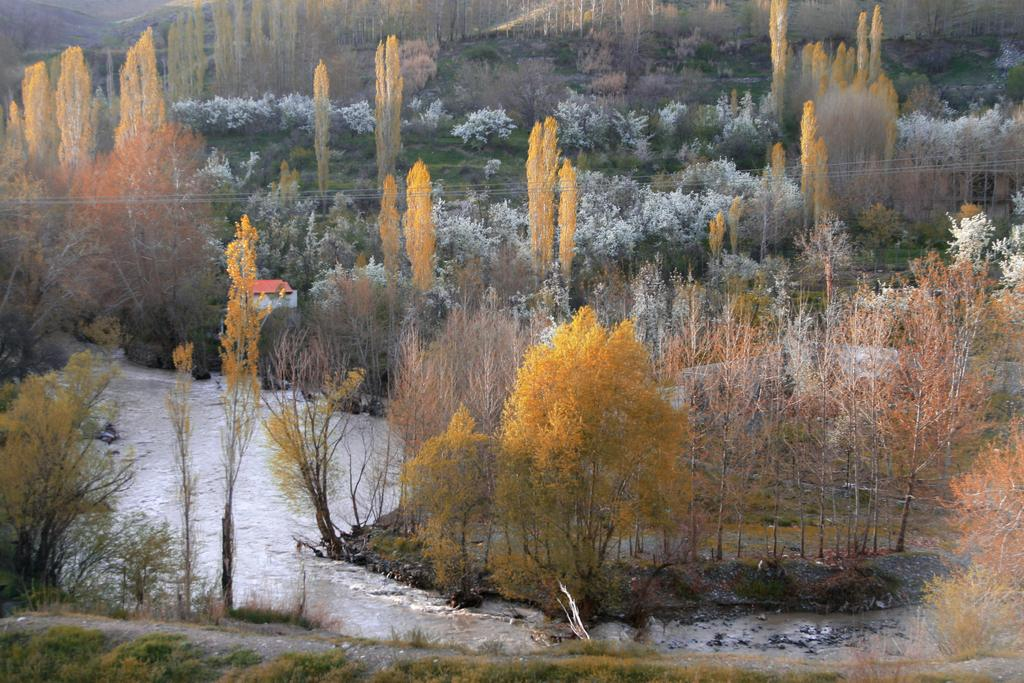What type of vegetation can be seen in the image? There are trees and plants visible in the image. What else can be seen in the image besides vegetation? There is water visible in the image. Can you describe the water in the image? The water is not described in the provided facts, so we cannot provide more details about it. What type of needle is being used to perform addition in the image? There is no needle or addition activity present in the image. 